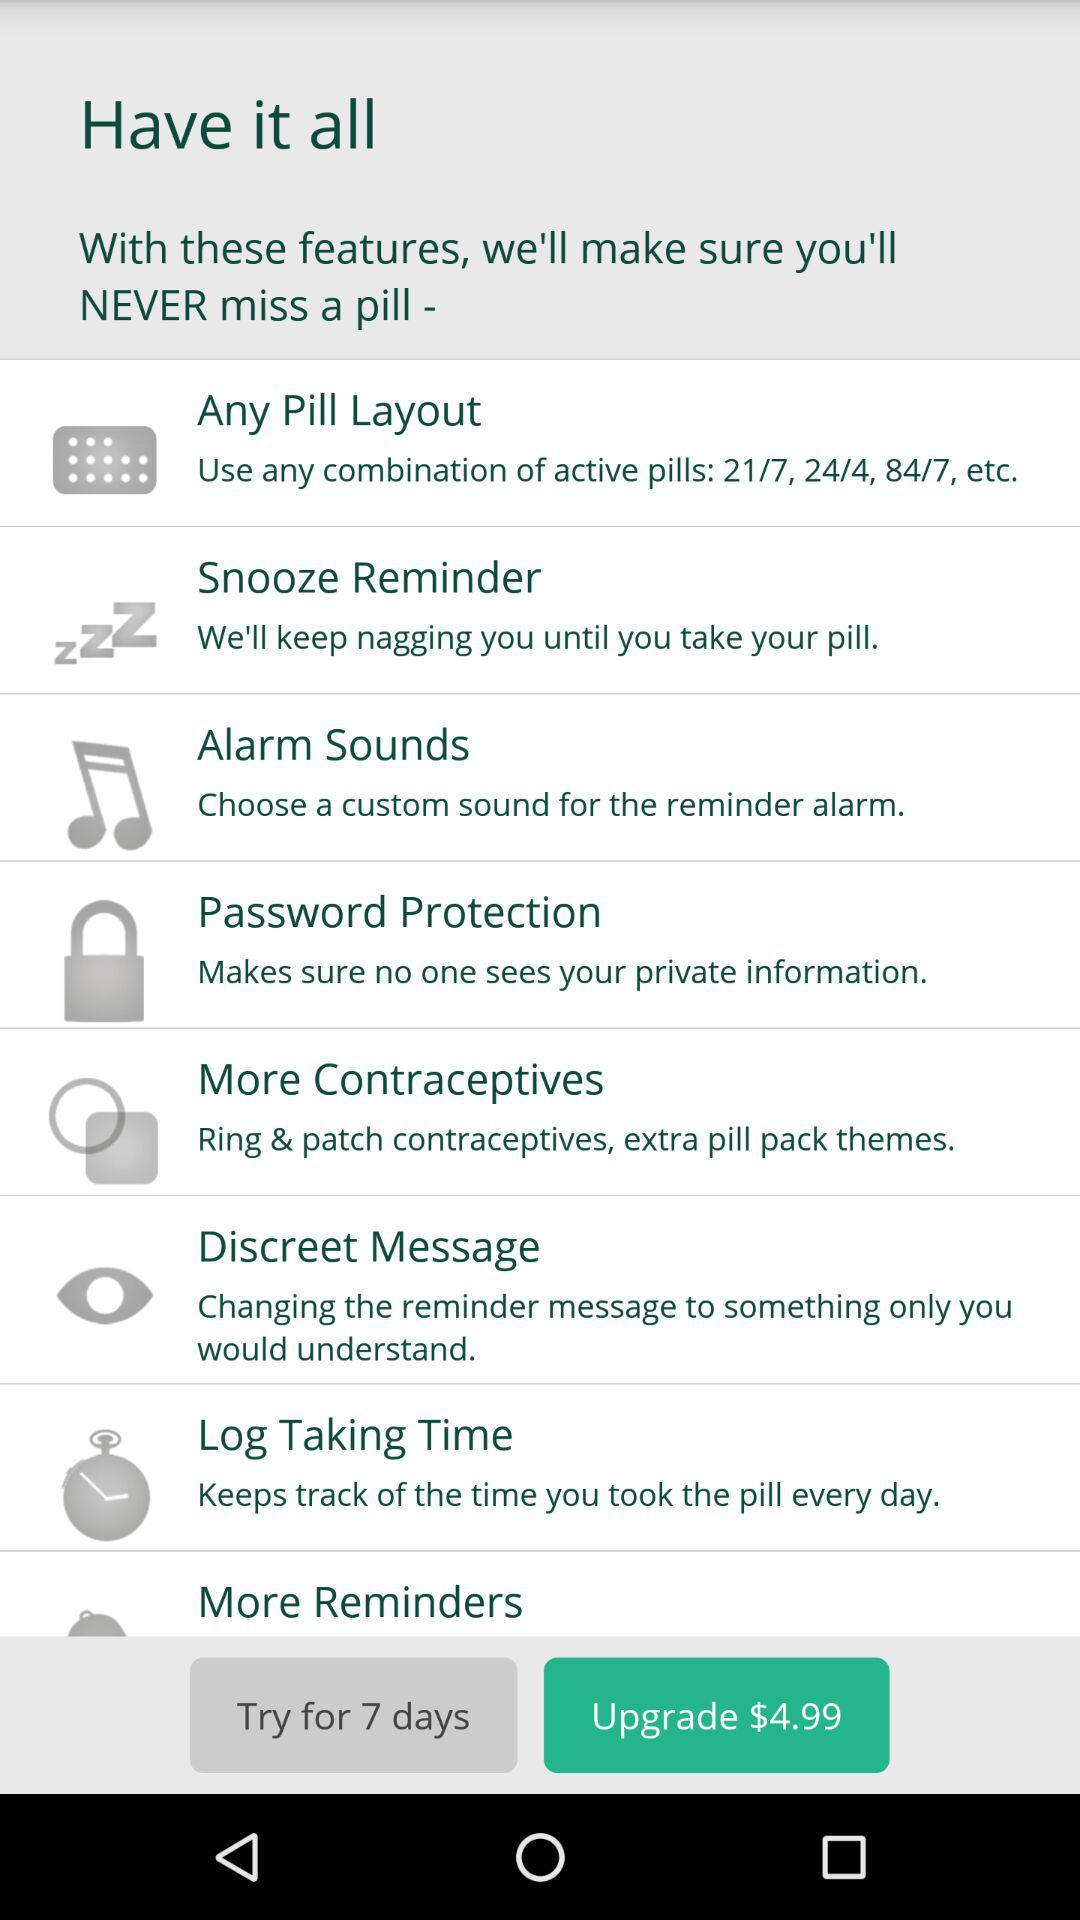What are the different combinations of active pill layout given? The different combinations are 21/7, 24/4, 84/7 etc. 